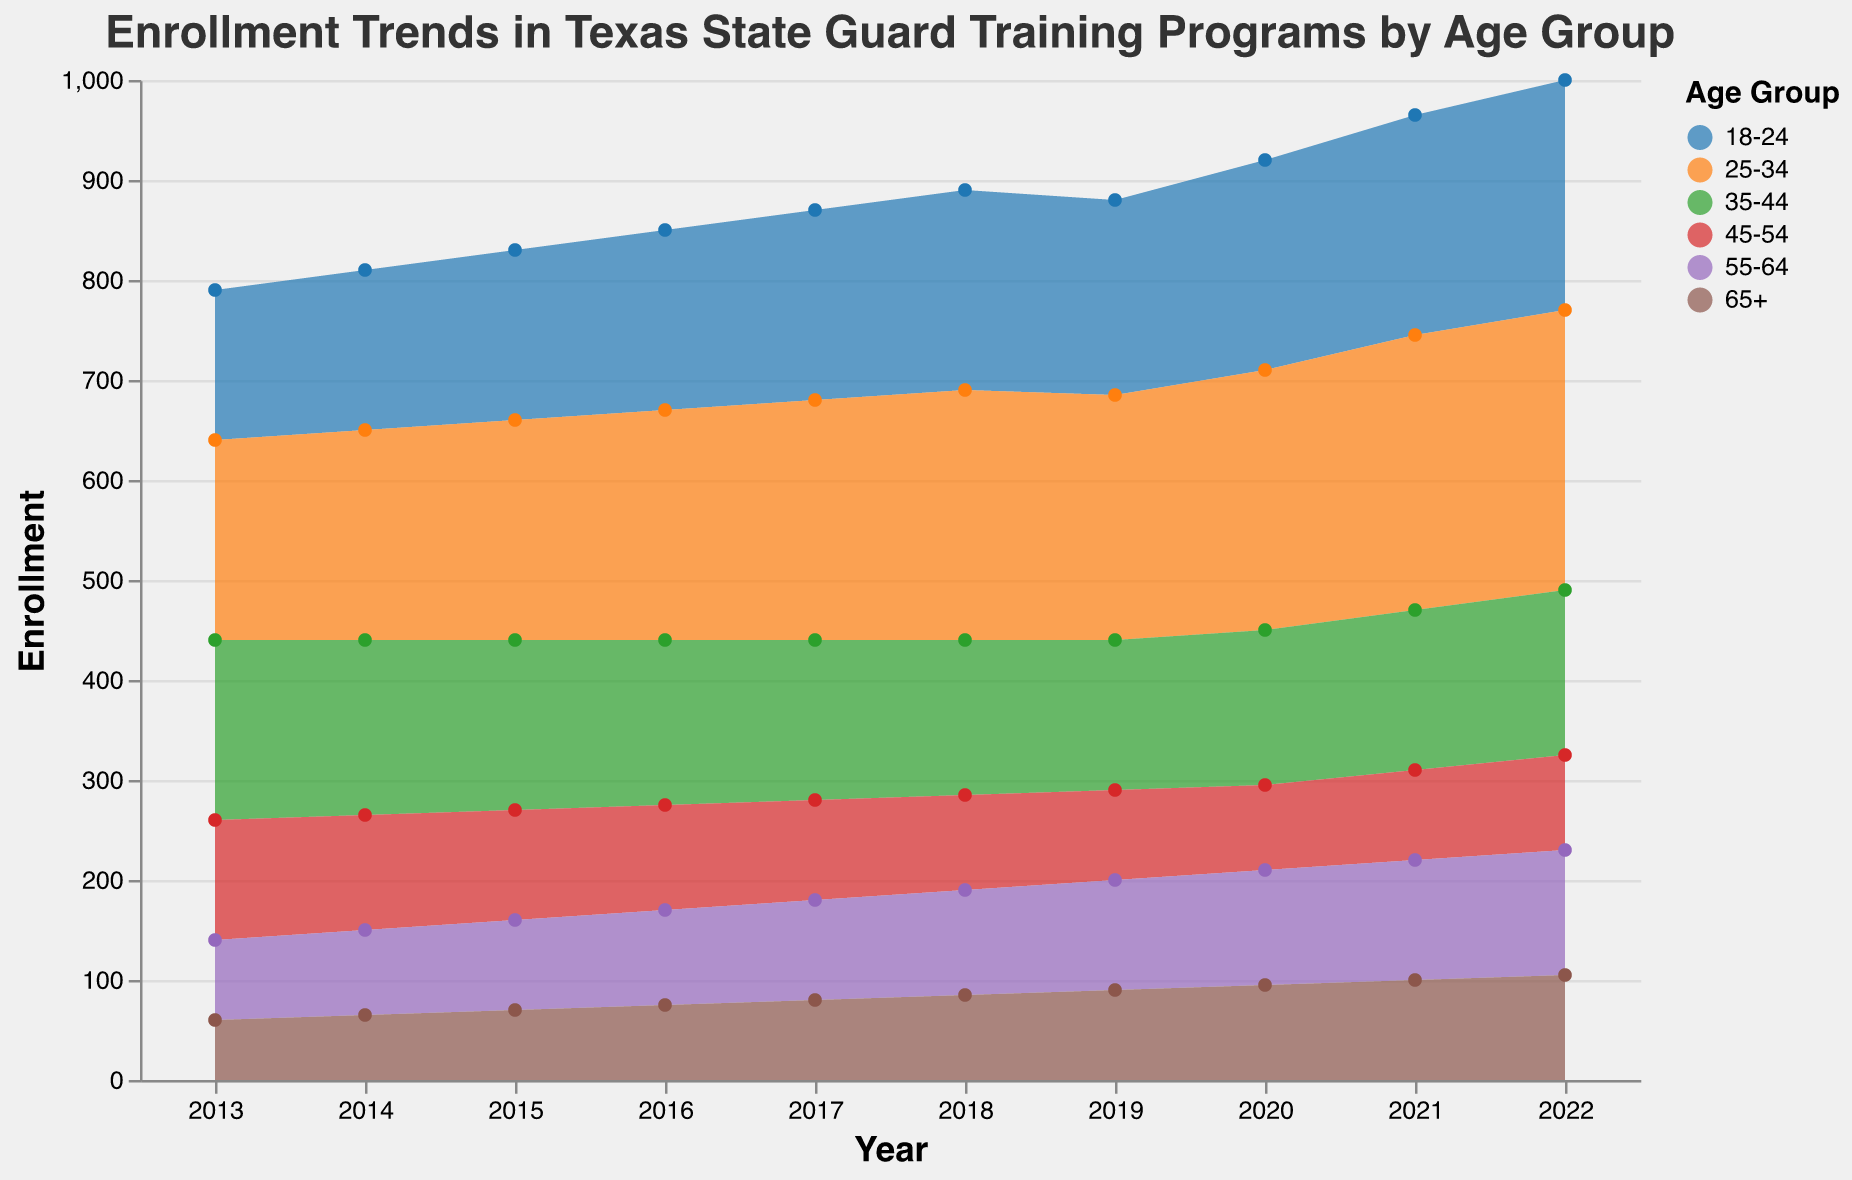What is the title of the figure? The title of the figure is prominently displayed at the top and provides a description of what the figure is about.
Answer: Enrollment Trends in Texas State Guard Training Programs by Age Group Which age group had the highest enrollment in 2022? By looking at the colors representing different age groups and the corresponding values on the vertical axis for 2022, the age group with the tallest area is identified.
Answer: 25-34 How did the enrollment for age group 45-54 change from 2013 to 2022? The enrollment starts at 120 in 2013 and generally decreases over the years, reaching 95 in 2022. This can be observed by following the area's height for the age group over the years.
Answer: Decreased Which age group shows a consistent increase in enrollment every year? Observing all age groups' trends over the years will reveal that 65+ consistently increases without any decreases or plateaus.
Answer: 65+ What is the total enrollment for all age groups in 2018? To find the total enrollment, sum the enrollment values of all age groups for the year 2018. These values are: 200 + 250 + 155 + 95 + 105 + 85.
Answer: 890 Compare the enrollment trend for age groups 18-24 and 35-44 from 2013 to 2022. By comparing the trends, the enrollment for 18-24 generally increases, whereas the enrollment for 35-44 decreases initially and then slightly increases toward the end.
Answer: 18-24 increases, 35-44 decreases then slightly rises Which age group has the most volatile trend over the past decade? Examine the fluctuations in the height of the area representing each age group. The group with the most ups and downs is considered most volatile.
Answer: 35-44 What was the enrollment number for the age group 18-24 in the year 2020? Find the color corresponding to the age group 18-24 and trace the value for the year 2020 on the vertical axis.
Answer: 210 